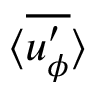Convert formula to latex. <formula><loc_0><loc_0><loc_500><loc_500>\langle \overline { { u _ { \phi } ^ { \prime } } } \rangle</formula> 